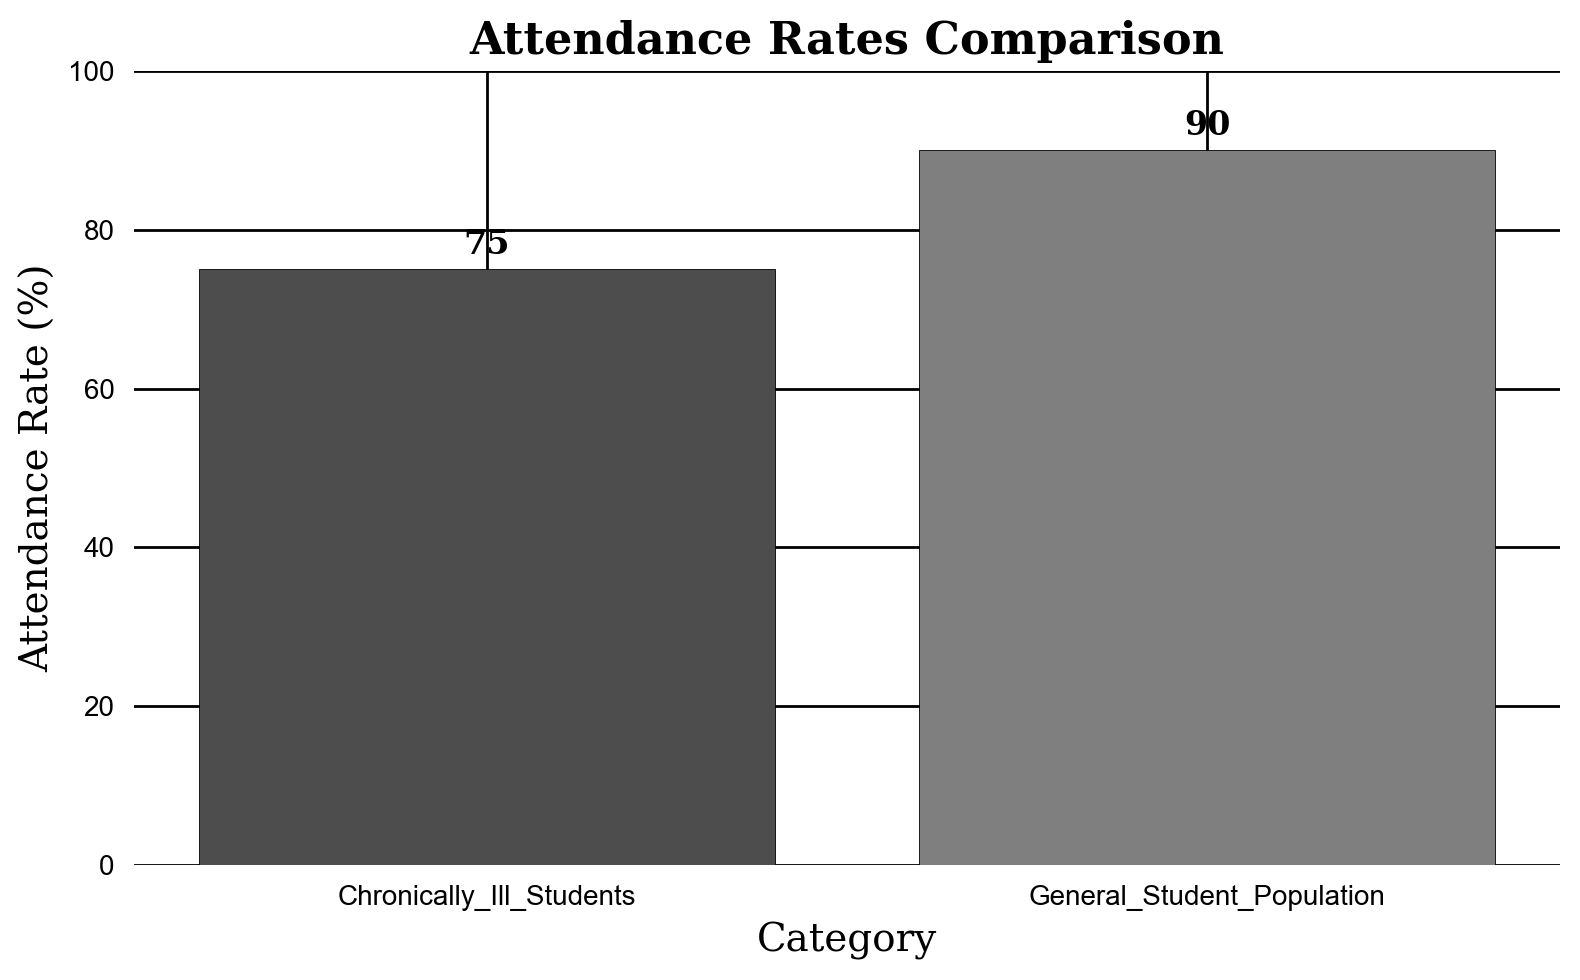What is the difference in attendance rates between chronically ill students and the general student population? To find the difference, subtract the attendance rate of chronically ill students (75%) from that of the general student population (90%). \( 90 - 75 = 15 \). The difference is 15%.
Answer: 15% Which category has a higher attendance rate? By comparing the heights of the bars, it is clear that the general student population has a higher attendance rate (90%) than the chronically ill students (75%).
Answer: General student population What is the attendance rate of chronically ill students? The attendance rate of chronically ill students is presented directly on the bar labeled "Chronically Ill Students" which is 75%.
Answer: 75% By how much does the attendance rate of the general student population exceed 80%? To find the excess, subtract 80% from the general student population's attendance rate (90%). \( 90 - 80 = 10 \). The general student population exceeds 80% by 10%.
Answer: 10% What is the visual difference in height between the two bars? The bar representing the general student population reaches 90% on the y-axis, while the bar for chronically ill students reaches 75%. This means the visual difference in height is \( 90 - 75 = 15 \) percentage points.
Answer: 15 percentage points What is the combined attendance rate of both groups? To find the combined attendance rate, add the attendance rates of the chronically ill students and the general student population: \( 75 + 90 = 165 \)%.
Answer: 165% What is the average attendance rate of both categories? The average attendance rate can be found by adding the two rates (75% and 90%) and then dividing by 2. \((75 + 90)/2 = 165/2 = 82.5%\).
Answer: 82.5% What percentage of improvement would be needed for chronically ill students to reach the attendance rate of the general student population? To find the required improvement, subtract the chronically ill students' attendance rate from the general student population's rate: \( 90 - 75 = 15 \). Then, to find the percentage improvement relative to the chronically ill students' rate: \((15/75) \times 100 = 20\)%. This means a 20% improvement is needed.
Answer: 20% Which bar is darker in color, and what does it represent? The bar representing the chronically ill students (75%) is darker in color.
Answer: Chronically ill students What would be the attendance rate of chronically ill students if it increased by 10 percentage points? Adding 10 percentage points to the current rate of 75%: \( 75 + 10 = 85 \)%. So, the new rate would be 85%.
Answer: 85% 